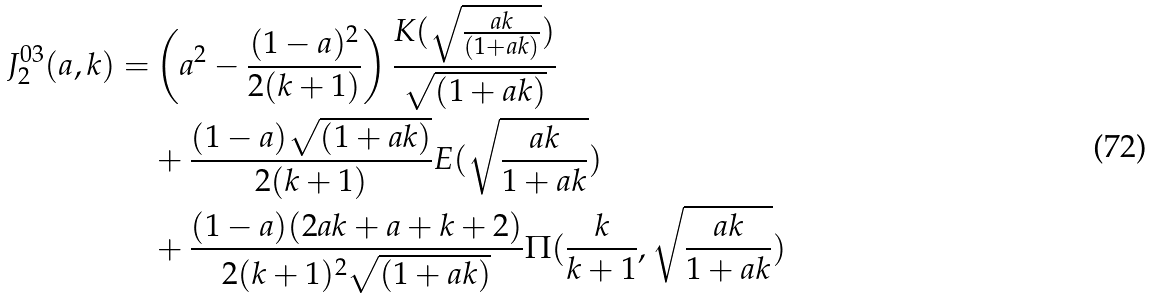<formula> <loc_0><loc_0><loc_500><loc_500>J _ { 2 } ^ { 0 3 } ( a , k ) = & \left ( a ^ { 2 } - \frac { ( 1 - a ) ^ { 2 } } { 2 ( k + 1 ) } \right ) \frac { K ( \sqrt { \frac { a k } { ( 1 + a k ) } } ) } { \sqrt { ( 1 + a k ) } } \\ & + \frac { ( 1 - a ) \sqrt { ( 1 + a k ) } } { 2 ( k + 1 ) } E ( \sqrt { \frac { a k } { 1 + a k } } ) \\ & + \frac { ( 1 - a ) ( 2 a k + a + k + 2 ) } { 2 ( k + 1 ) ^ { 2 } \sqrt { ( 1 + a k ) } } \Pi ( \frac { k } { k + 1 } , \sqrt { \frac { a k } { 1 + a k } } )</formula> 